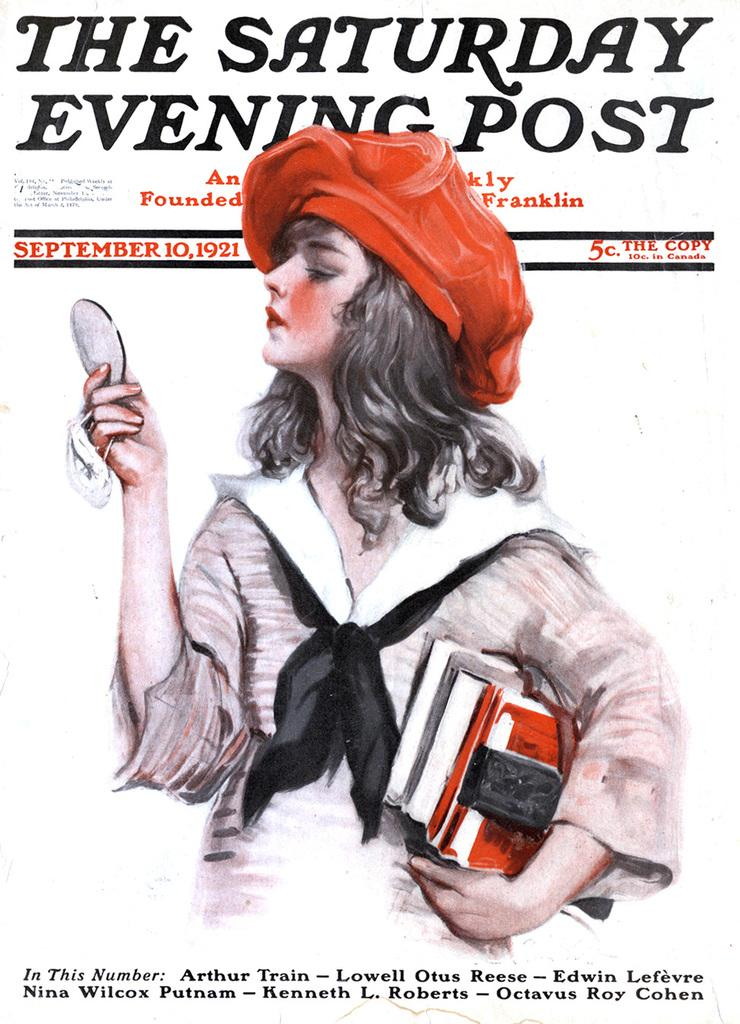Who is the main subject of the poster? The poster features a lady. What is the lady wearing on her head? The lady is wearing a cap. What is the lady holding in her hands? The lady is holding books and something else in her hand. What can be seen in addition to the lady and her items? There is text written on the image. What type of alarm can be heard going off in the image? There is no alarm present in the image, and therefore no sound can be heard. What type of gate is visible in the image? There is no gate visible in the image. 